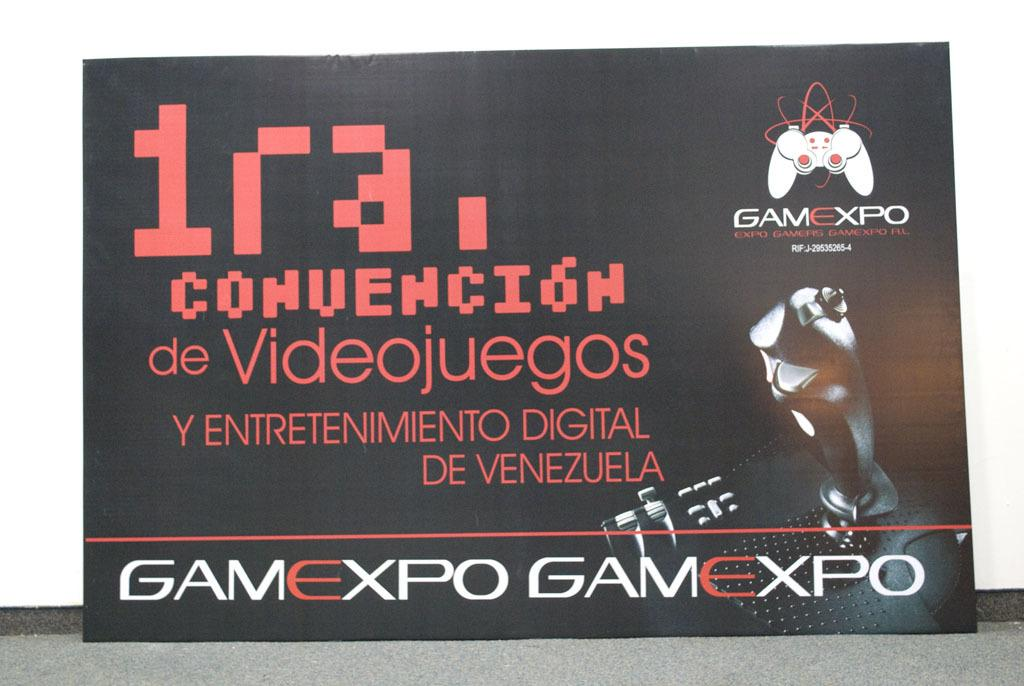What is the main subject in the center of the image? There is a banner in the center of the image. What does the banner say? The banner has the text "Game Expo" written on it. What can be seen in the background of the image? There is a wall in the background of the image. How many fingers are visible on the banner in the image? There are no fingers visible on the banner in the image; it only has the text "Game Expo" written on it. What type of trade is being promoted in the image? The image does not specifically promote any trade; it only features a banner for a "Game Expo." 